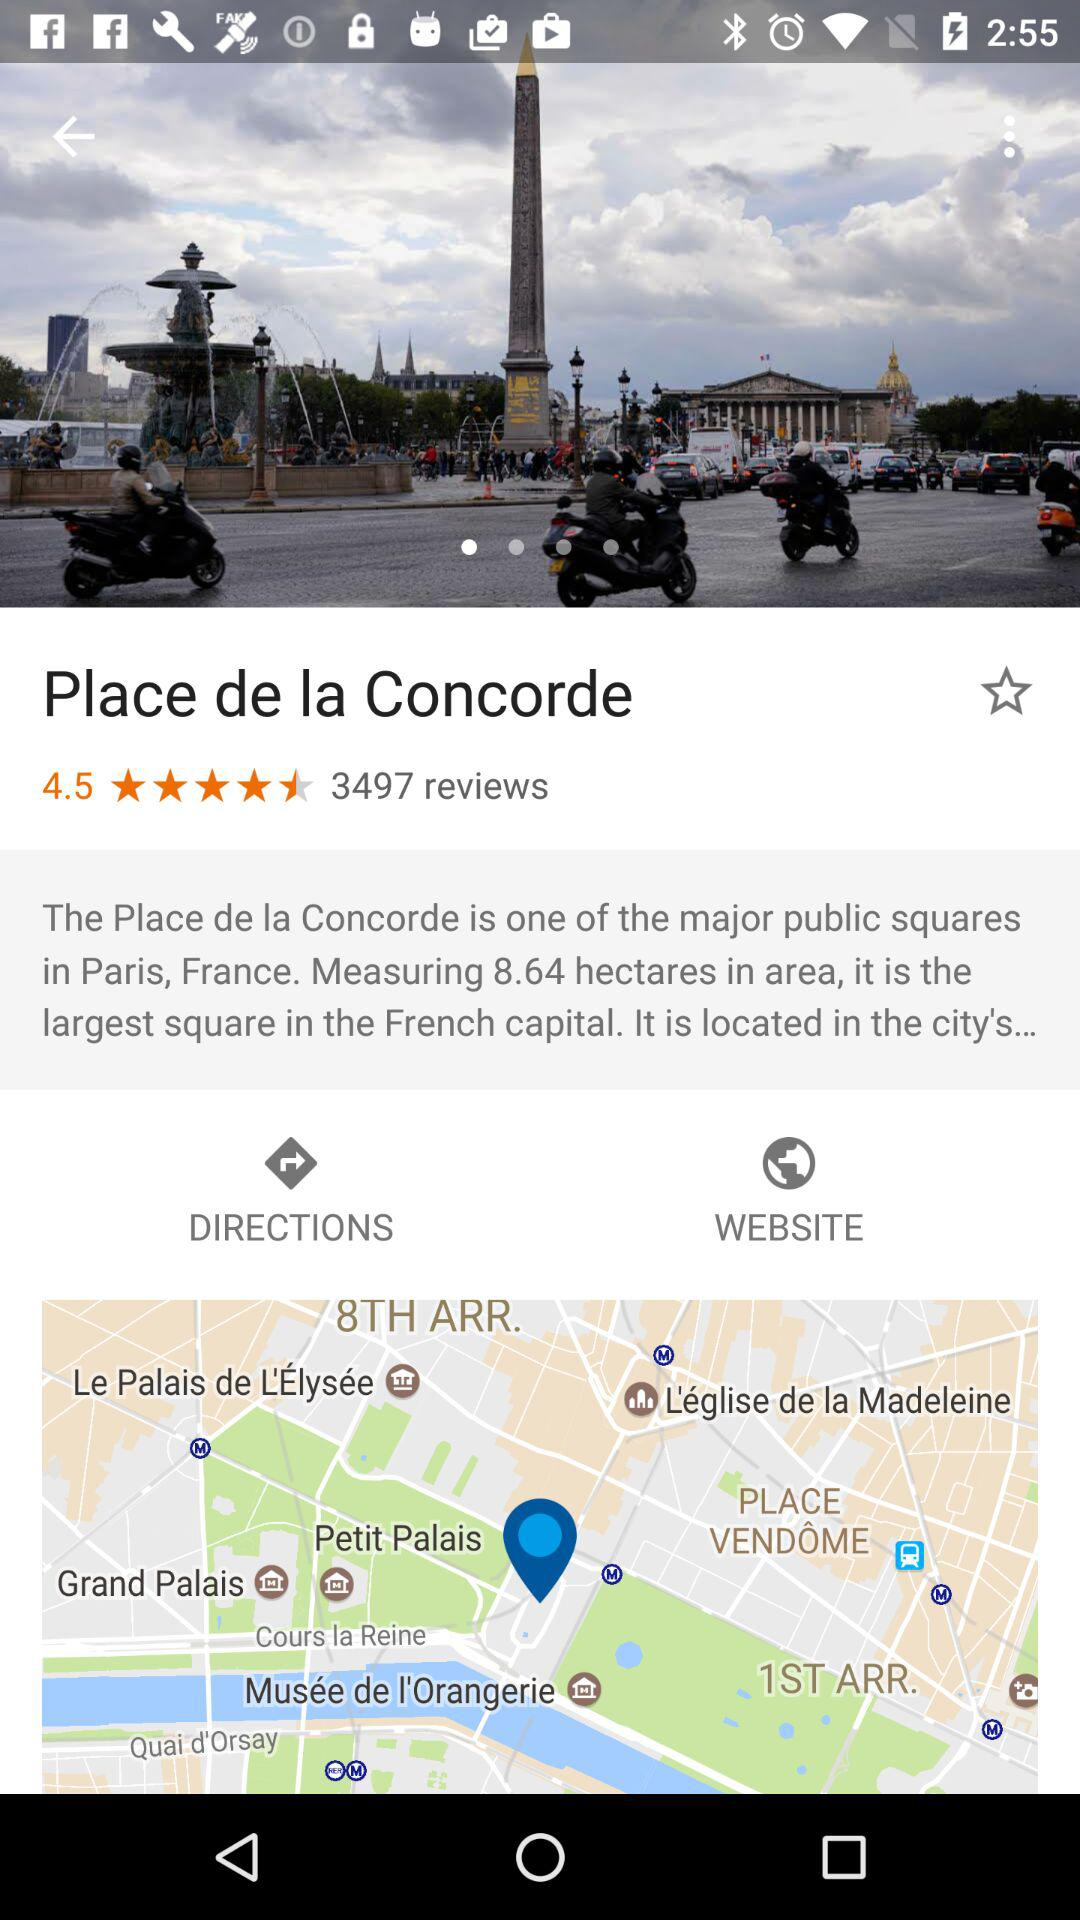How many more reviews does this place have than 1000?
Answer the question using a single word or phrase. 2497 